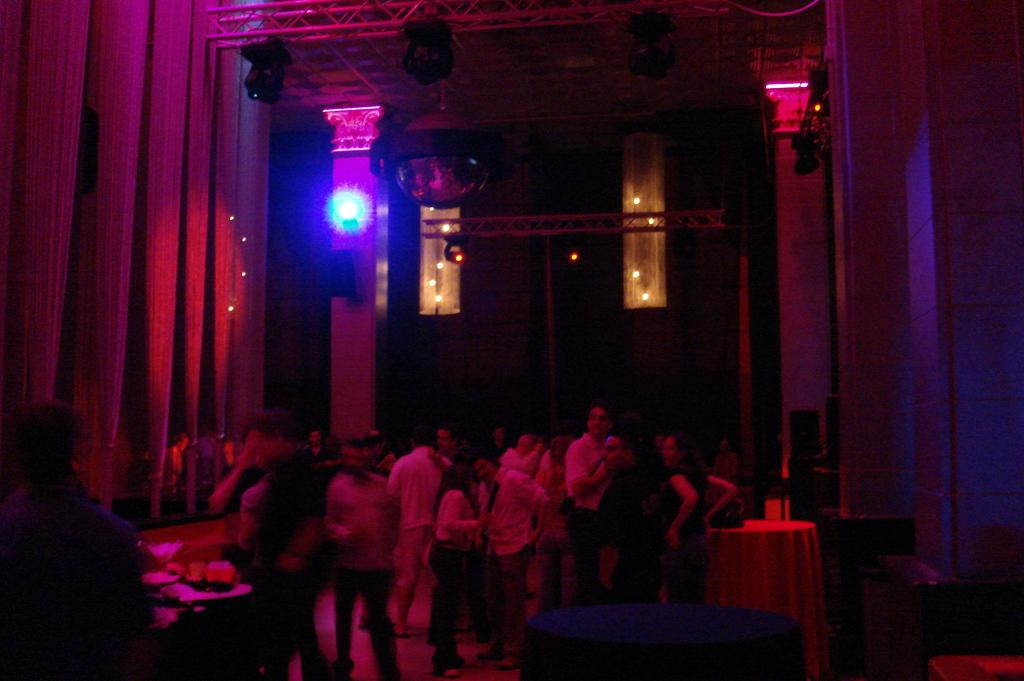What can be seen in the image regarding human presence? There are people standing in the image. Where are the people standing? The people are standing on the floor. What type of lighting is present in the image? There are electric lights in the image. What can be seen in the image that might be used for cooking? There are grills in the image. What is placed on a table in the image? Food is placed on a table in the image. How many dimes are visible on the grills in the image? There are no dimes present in the image; it features people standing, electric lights, grills, and food on a table. What type of ants can be seen crawling on the food in the image? There are no ants present in the image; it only shows people standing, electric lights, grills, and food on a table. 